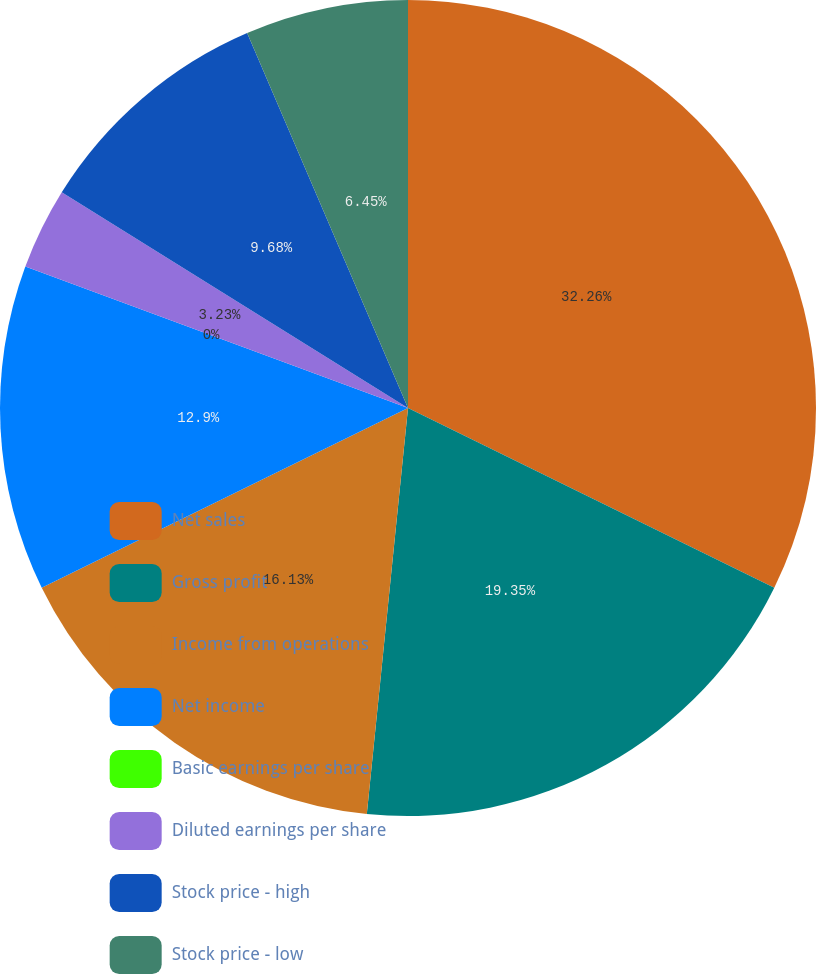Convert chart to OTSL. <chart><loc_0><loc_0><loc_500><loc_500><pie_chart><fcel>Net sales<fcel>Gross profit<fcel>Income from operations<fcel>Net income<fcel>Basic earnings per share<fcel>Diluted earnings per share<fcel>Stock price - high<fcel>Stock price - low<nl><fcel>32.26%<fcel>19.35%<fcel>16.13%<fcel>12.9%<fcel>0.0%<fcel>3.23%<fcel>9.68%<fcel>6.45%<nl></chart> 